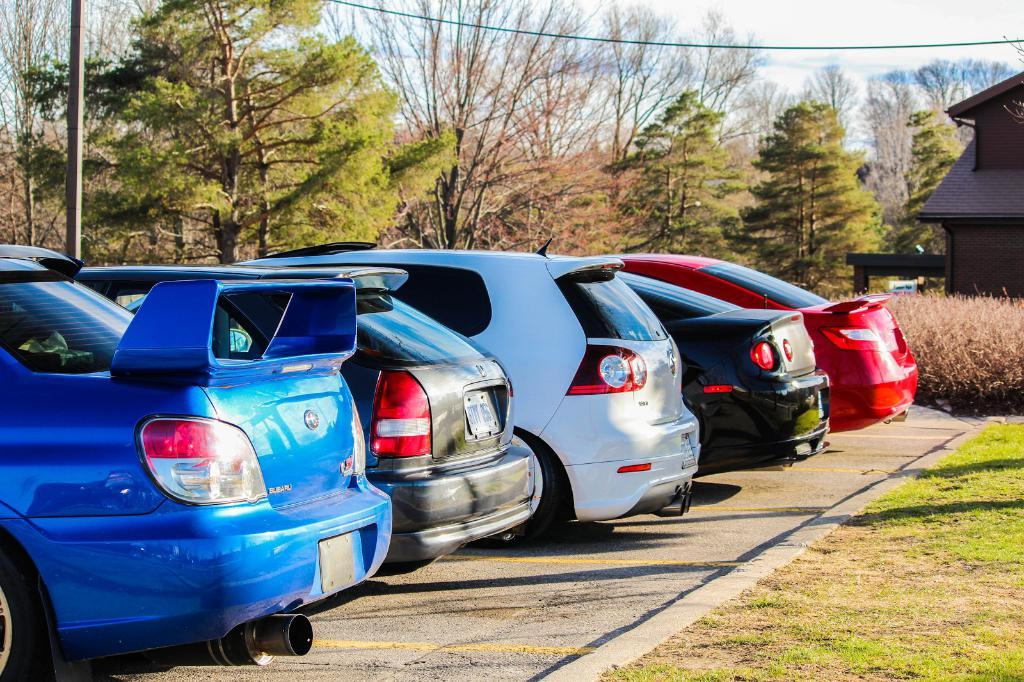What type of vehicles can be seen in the image? There are cars in the image. What other objects or features can be seen in the image? There are trees and a shed on the right side of the image. What is visible in the background of the image? The sky is visible in the background of the image. Can you find the receipt for the purchase of the shed in the image? There is no receipt present in the image. What type of quiver is visible on the trees in the image? There is no quiver present in the image; it features cars, trees, and a shed. 